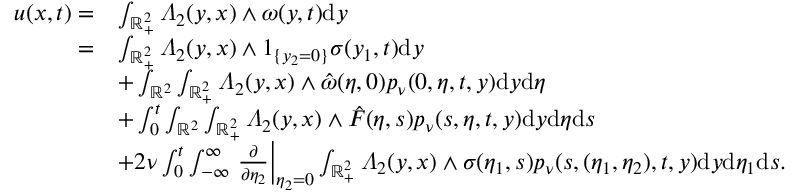<formula> <loc_0><loc_0><loc_500><loc_500>\begin{array} { r l } { u ( x , t ) = } & { \int _ { \mathbb { R } _ { + } ^ { 2 } } \varLambda _ { 2 } ( y , x ) \wedge \omega ( y , t ) d y } \\ { = } & { \int _ { \mathbb { R } _ { + } ^ { 2 } } \varLambda _ { 2 } ( y , x ) \wedge 1 _ { \{ y _ { 2 } = 0 \} } \sigma ( y _ { 1 } , t ) d y } \\ & { + \int _ { \mathbb { R } ^ { 2 } } \int _ { \mathbb { R } _ { + } ^ { 2 } } \varLambda _ { 2 } ( y , x ) \wedge \hat { \omega } ( \eta , 0 ) p _ { \nu } ( 0 , \eta , t , y ) d y d \eta } \\ & { + \int _ { 0 } ^ { t } \int _ { \mathbb { R } ^ { 2 } } \int _ { \mathbb { R } _ { + } ^ { 2 } } \varLambda _ { 2 } ( y , x ) \wedge \hat { F } ( \eta , s ) p _ { \nu } ( s , \eta , t , y ) d y d \eta d s } \\ & { + 2 \nu \int _ { 0 } ^ { t } \int _ { - \infty } ^ { \infty } \frac { \partial } { \partial \eta _ { 2 } } \right | _ { \eta _ { 2 } = 0 } \int _ { \mathbb { R } _ { + } ^ { 2 } } \varLambda _ { 2 } ( y , x ) \wedge \sigma ( \eta _ { 1 } , s ) p _ { \nu } ( s , ( \eta _ { 1 } , \eta _ { 2 } ) , t , y ) d y d \eta _ { 1 } d s . } \end{array}</formula> 